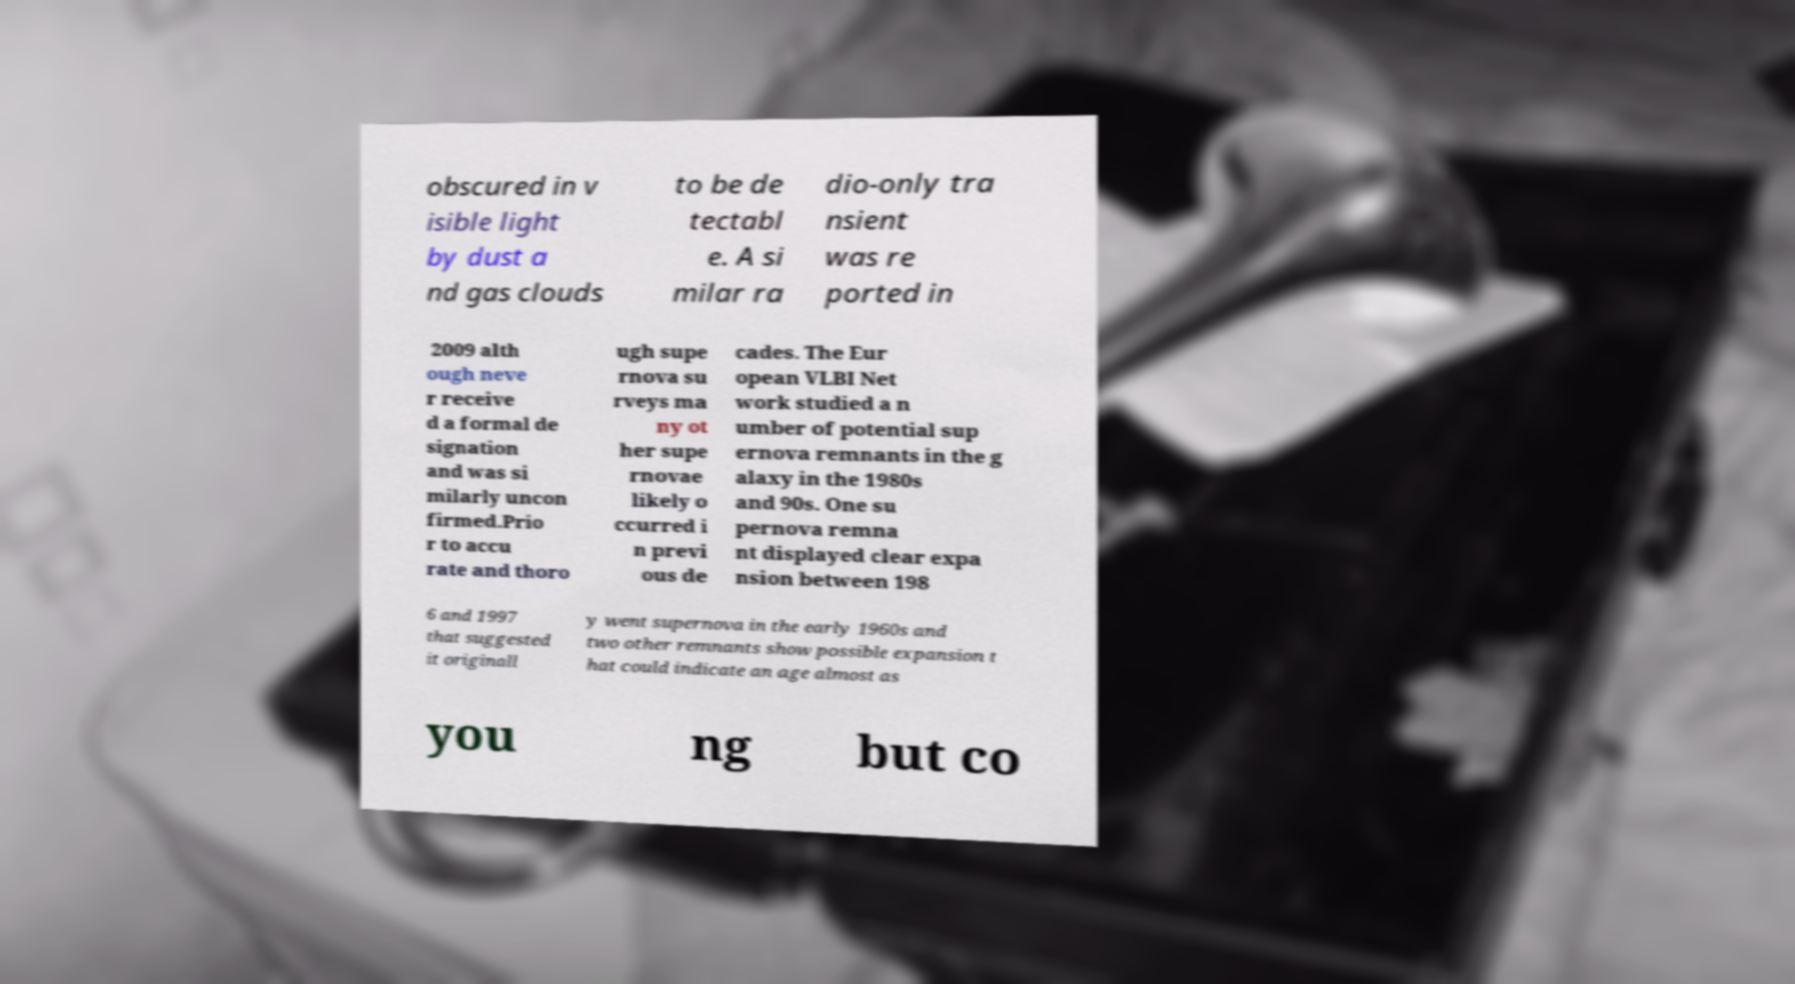Can you accurately transcribe the text from the provided image for me? obscured in v isible light by dust a nd gas clouds to be de tectabl e. A si milar ra dio-only tra nsient was re ported in 2009 alth ough neve r receive d a formal de signation and was si milarly uncon firmed.Prio r to accu rate and thoro ugh supe rnova su rveys ma ny ot her supe rnovae likely o ccurred i n previ ous de cades. The Eur opean VLBI Net work studied a n umber of potential sup ernova remnants in the g alaxy in the 1980s and 90s. One su pernova remna nt displayed clear expa nsion between 198 6 and 1997 that suggested it originall y went supernova in the early 1960s and two other remnants show possible expansion t hat could indicate an age almost as you ng but co 